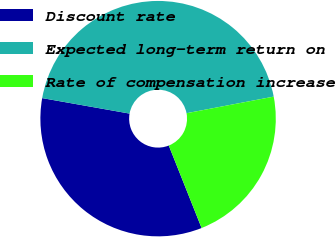<chart> <loc_0><loc_0><loc_500><loc_500><pie_chart><fcel>Discount rate<fcel>Expected long-term return on<fcel>Rate of compensation increase<nl><fcel>33.82%<fcel>44.21%<fcel>21.97%<nl></chart> 